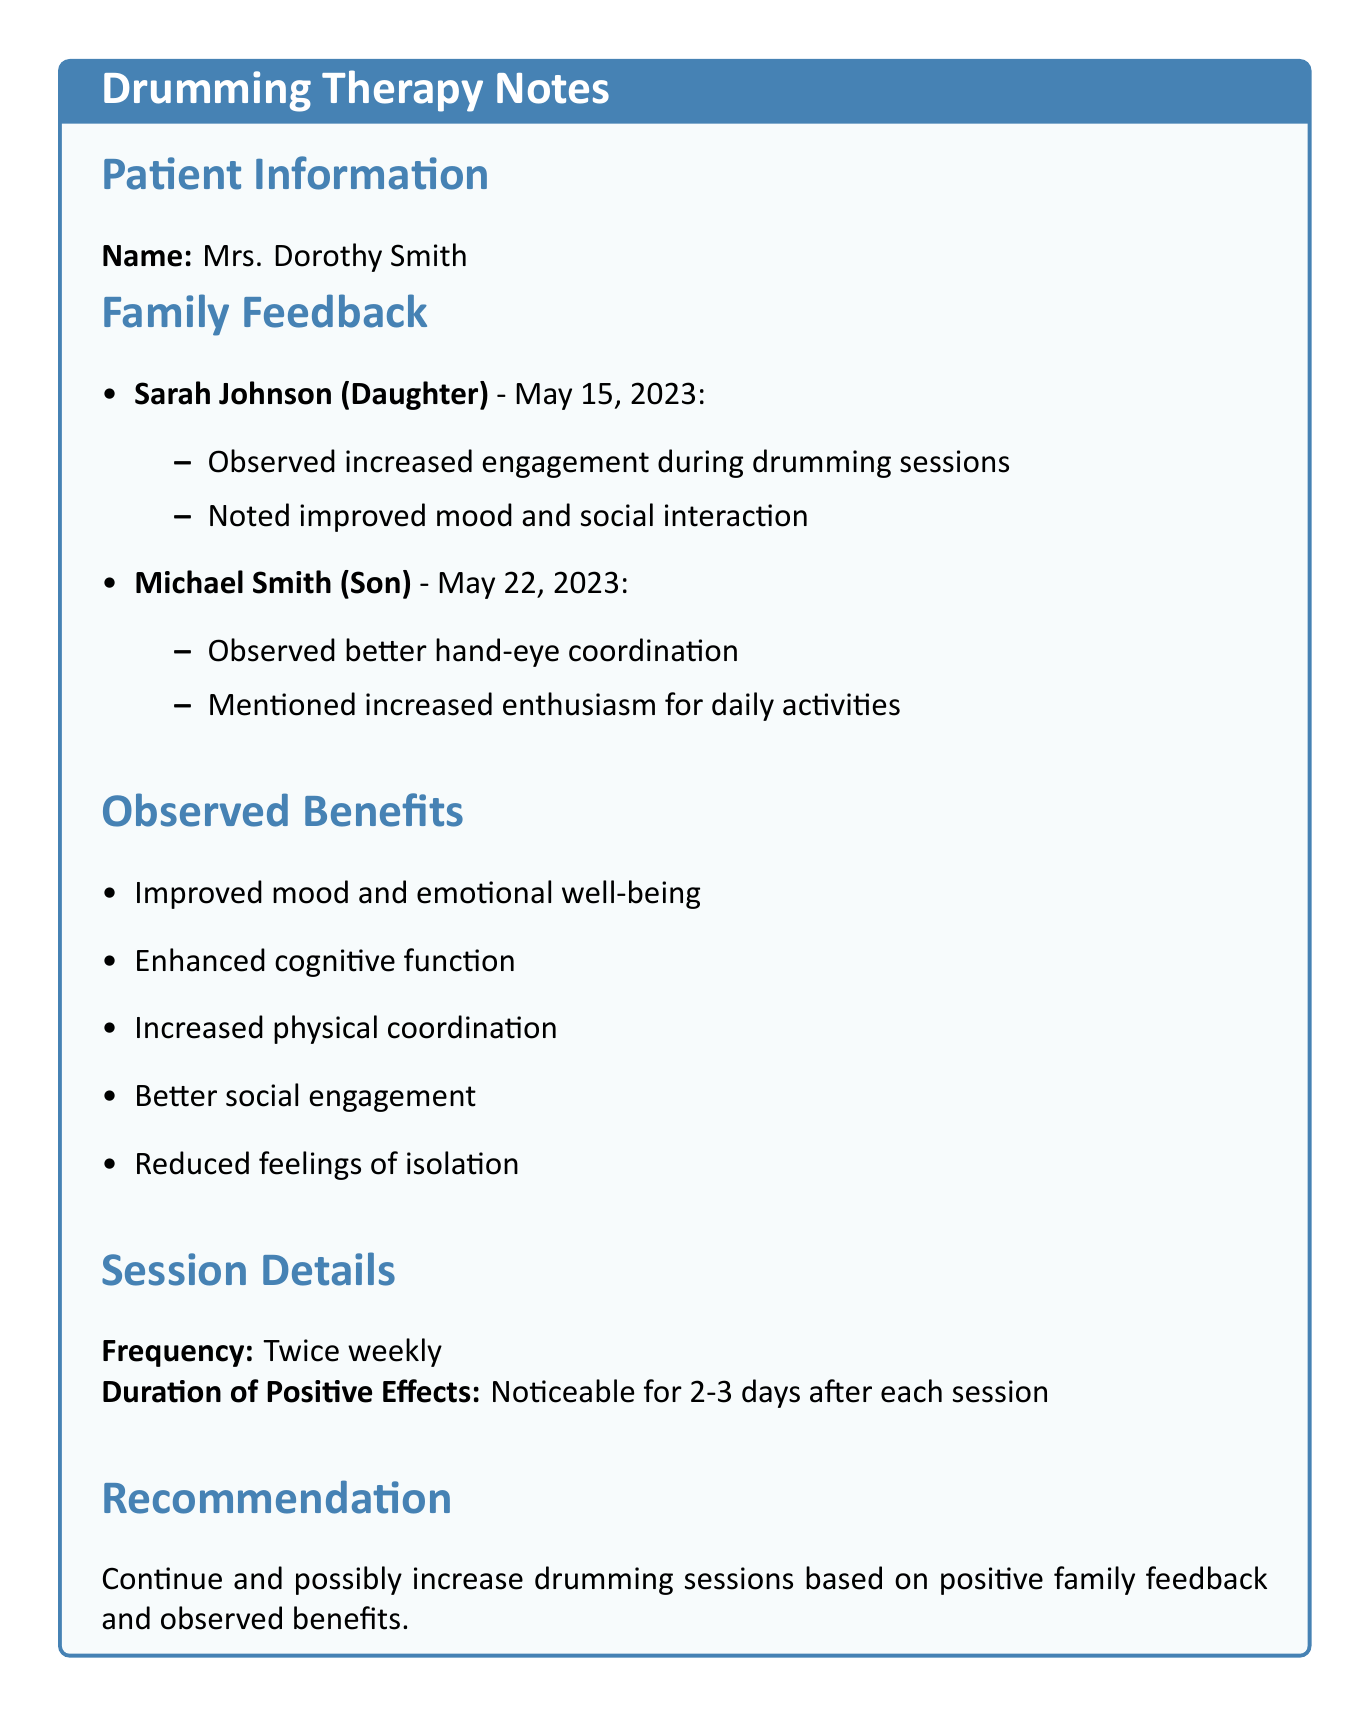What is the name of the patient? The name of the patient is listed at the top of the document under "Patient Information."
Answer: Mrs. Dorothy Smith Who is the daughter of the patient? The document provides information on family members, specifically their relations to the patient.
Answer: Sarah Johnson When did Sarah express her observations about her mother? The date of the conversation with Sarah is noted in her section of the document, outlining the time of her feedback.
Answer: May 15, 2023 What are the observed benefits of drumming? The document lists specific benefits in a section dedicated to them, which can be found under "Observed Benefits."
Answer: Improved mood and emotional well-being How often are the drumming sessions conducted? The frequency of the sessions is explicitly stated in the section detailing the session details.
Answer: Twice weekly What did Michael observe in his mother after drumming? This information is compiled from Michael's notes in the family feedback section of the document.
Answer: Better hand-eye coordination How long do the positive effects of drumming last? The duration of the positive effects is mentioned in the "Session Details" section of the document.
Answer: 2-3 days What is recommended regarding the drumming sessions? The recommendations about the sessions are provided in a specific section of the document summarizing family feedback.
Answer: Continue and possibly increase 